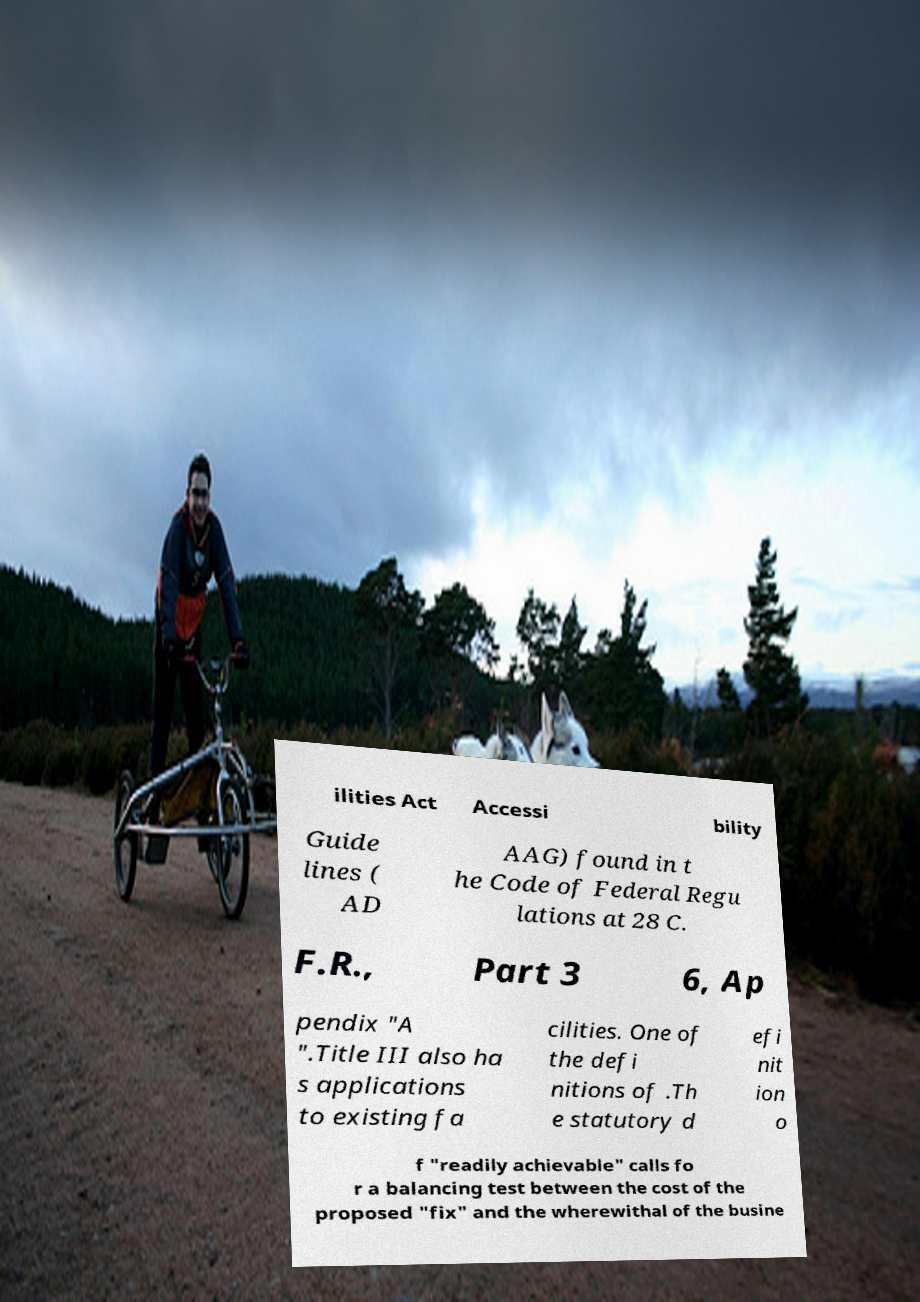Could you assist in decoding the text presented in this image and type it out clearly? ilities Act Accessi bility Guide lines ( AD AAG) found in t he Code of Federal Regu lations at 28 C. F.R., Part 3 6, Ap pendix "A ".Title III also ha s applications to existing fa cilities. One of the defi nitions of .Th e statutory d efi nit ion o f "readily achievable" calls fo r a balancing test between the cost of the proposed "fix" and the wherewithal of the busine 